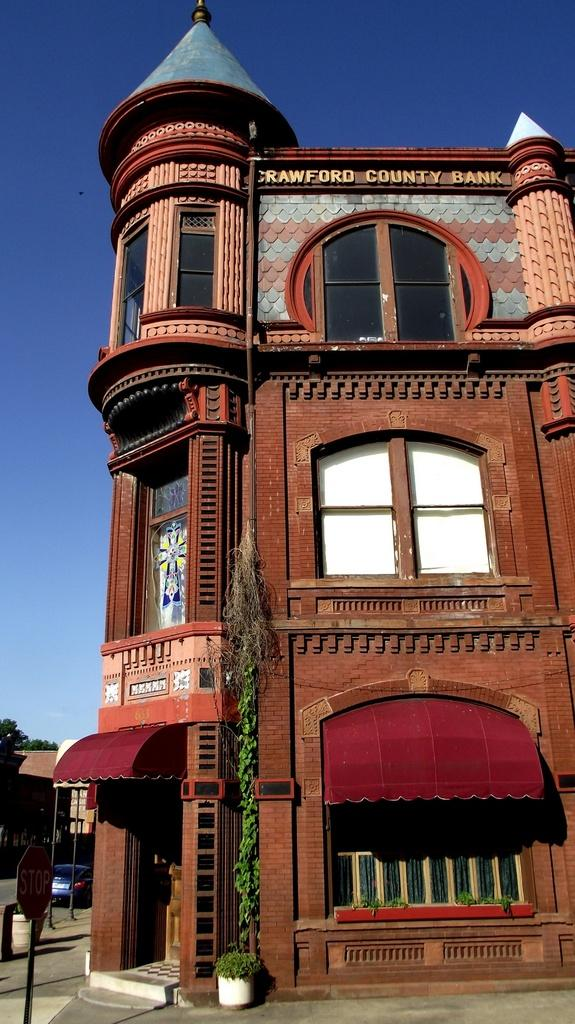What type of structure is visible in the image? There is a building in the image. What is attached to the pole in the image? There is a stop board attached to a pole in the image. What type of vehicle can be seen in the image? There is a car in the image. What type of vegetation is visible in the left corner of the image? There are trees in the left corner of the image. How many clams are sitting on the car in the image? There are no clams present in the image; it features a building, a stop board, a car, and trees. What type of news can be seen on the stop board in the image? The stop board in the image does not display any news; it is a traffic sign. 